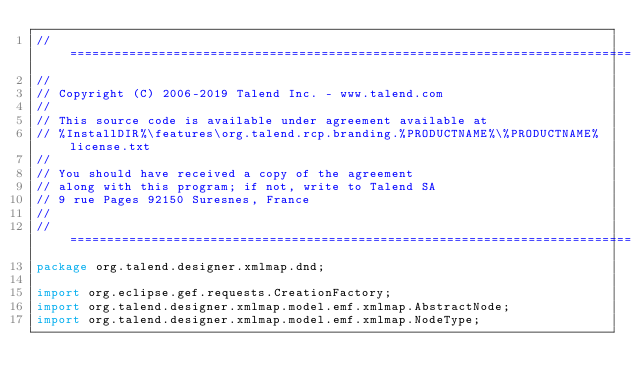<code> <loc_0><loc_0><loc_500><loc_500><_Java_>// ============================================================================
//
// Copyright (C) 2006-2019 Talend Inc. - www.talend.com
//
// This source code is available under agreement available at
// %InstallDIR%\features\org.talend.rcp.branding.%PRODUCTNAME%\%PRODUCTNAME%license.txt
//
// You should have received a copy of the agreement
// along with this program; if not, write to Talend SA
// 9 rue Pages 92150 Suresnes, France
//
// ============================================================================
package org.talend.designer.xmlmap.dnd;

import org.eclipse.gef.requests.CreationFactory;
import org.talend.designer.xmlmap.model.emf.xmlmap.AbstractNode;
import org.talend.designer.xmlmap.model.emf.xmlmap.NodeType;</code> 